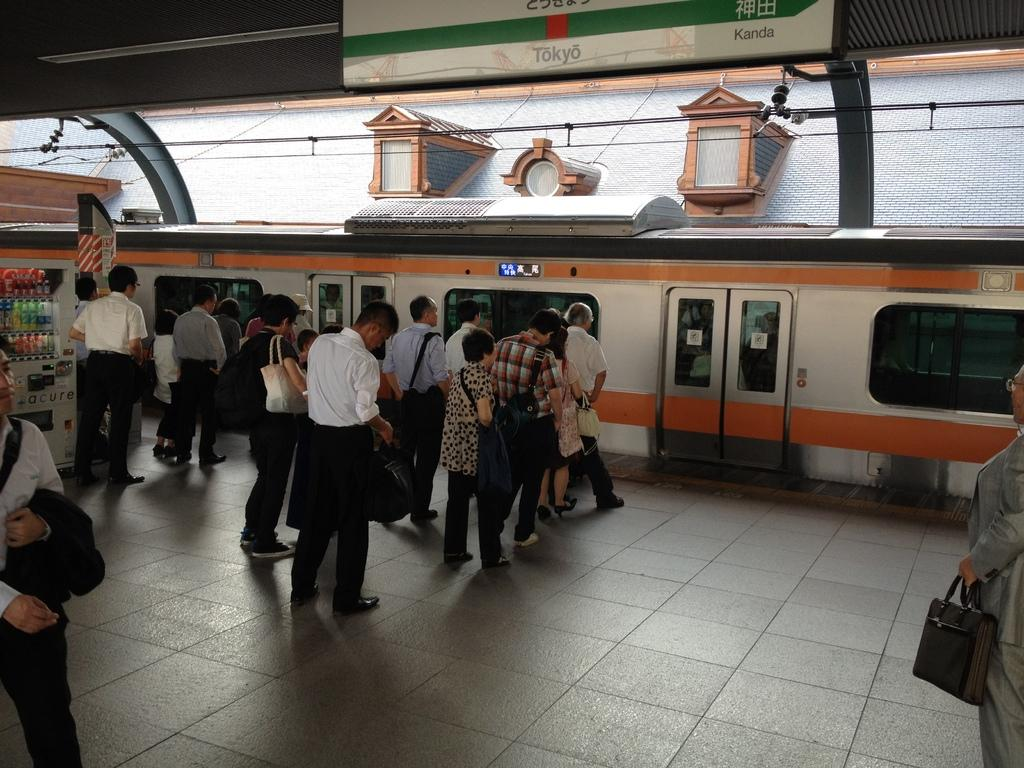What is the main subject of the image? The main subject of the image is a train on the tracks. What else can be seen in the image besides the train? There are people standing on a platform and a footstool in the image. What type of collar is the train wearing in the image? Trains do not wear collars, as they are not living beings. 